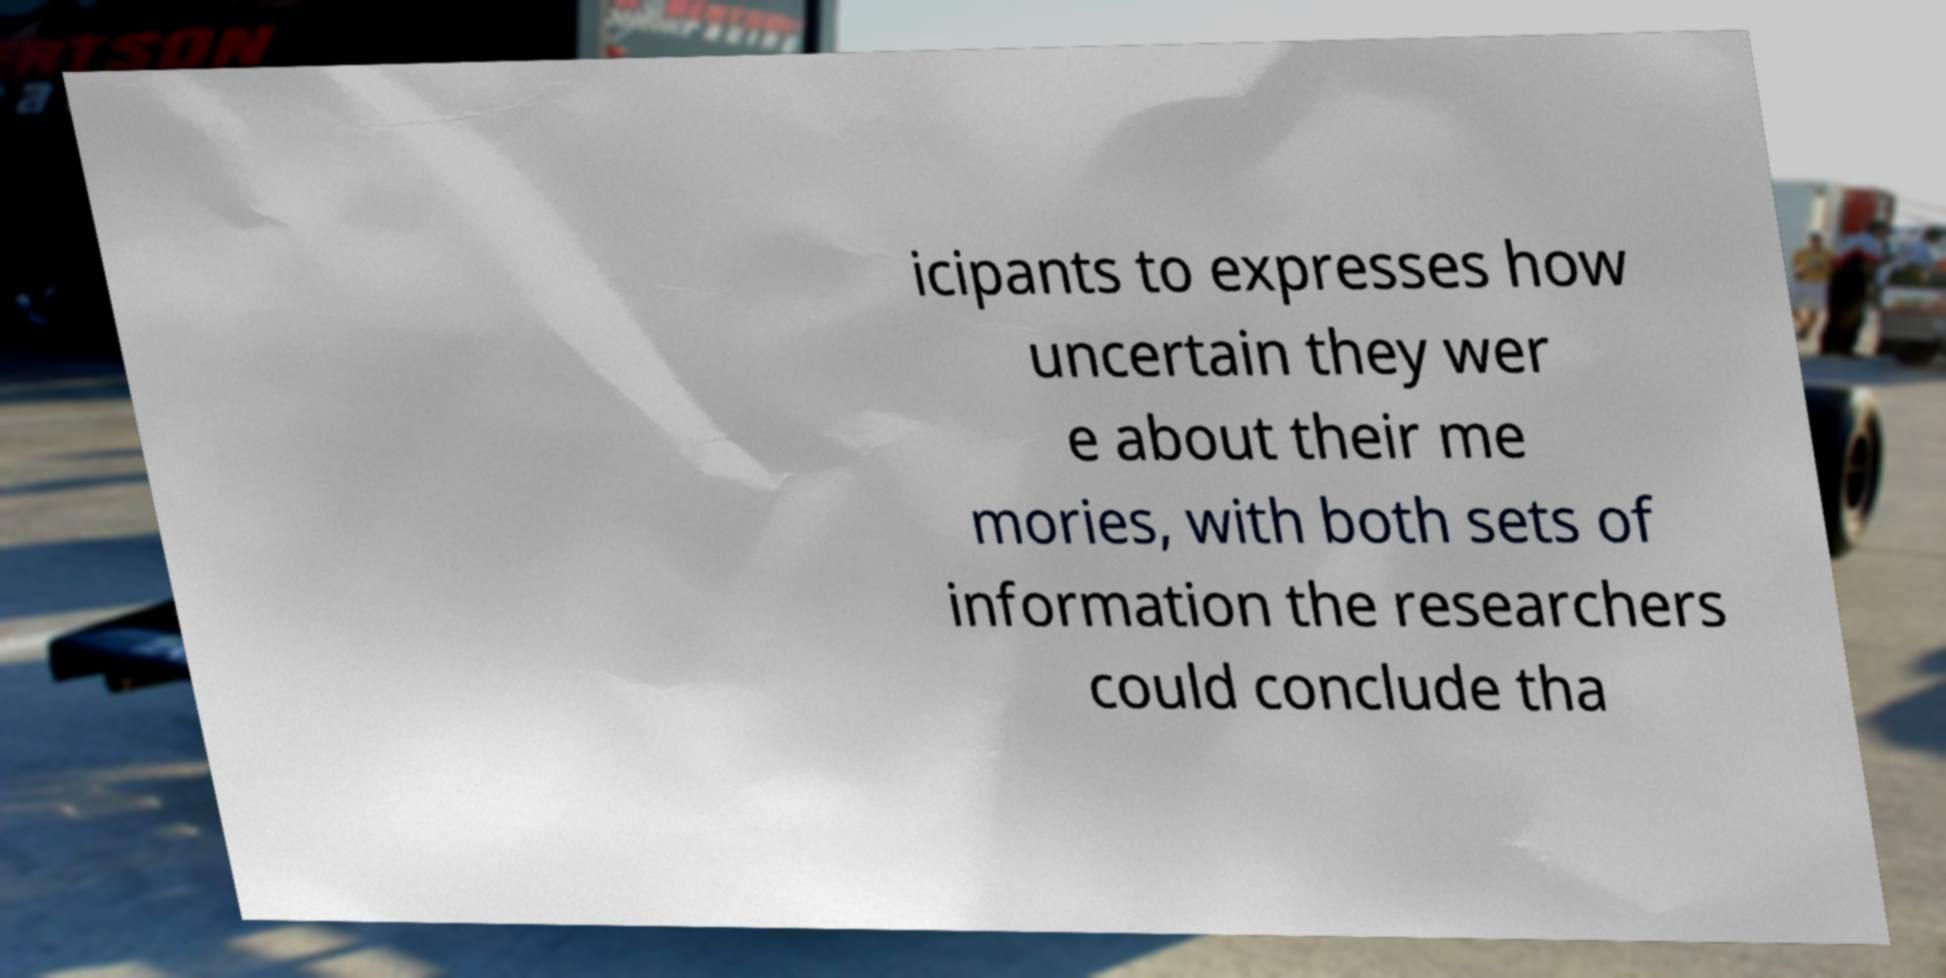Could you assist in decoding the text presented in this image and type it out clearly? icipants to expresses how uncertain they wer e about their me mories, with both sets of information the researchers could conclude tha 